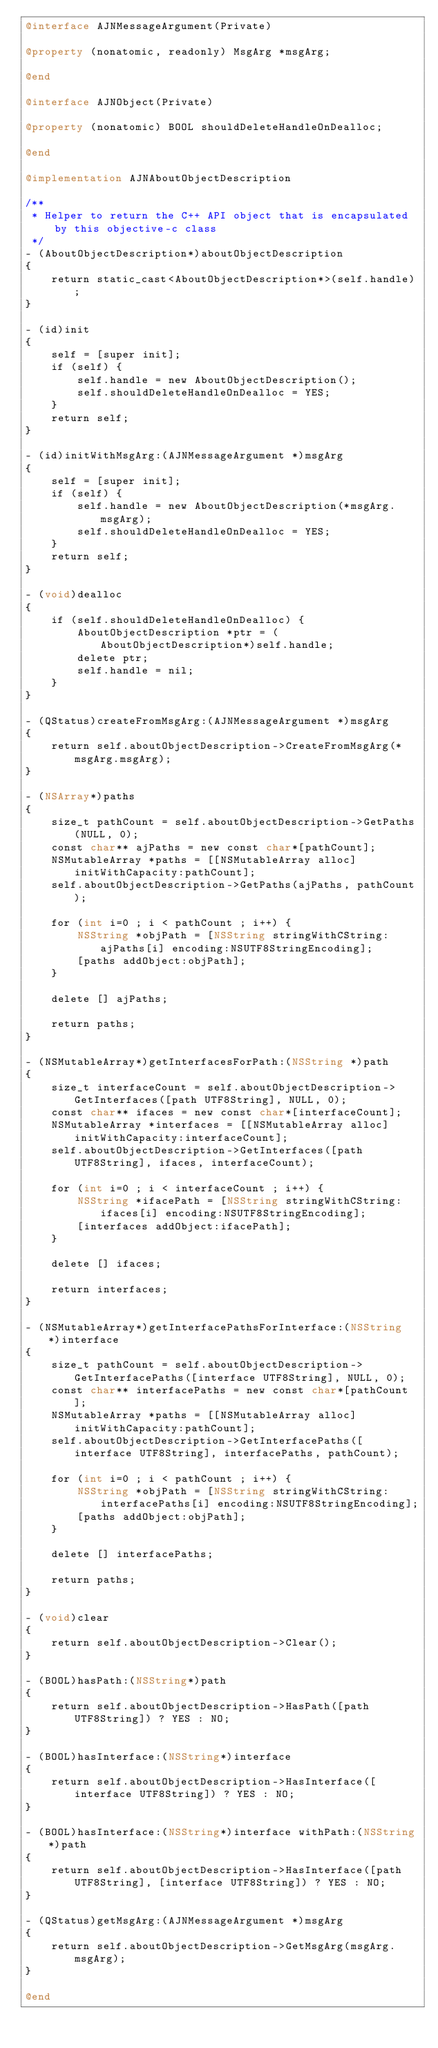<code> <loc_0><loc_0><loc_500><loc_500><_ObjectiveC_>@interface AJNMessageArgument(Private)

@property (nonatomic, readonly) MsgArg *msgArg;

@end

@interface AJNObject(Private)

@property (nonatomic) BOOL shouldDeleteHandleOnDealloc;

@end

@implementation AJNAboutObjectDescription

/**
 * Helper to return the C++ API object that is encapsulated by this objective-c class
 */
- (AboutObjectDescription*)aboutObjectDescription
{
    return static_cast<AboutObjectDescription*>(self.handle);
}

- (id)init
{
    self = [super init];
    if (self) {
        self.handle = new AboutObjectDescription();
        self.shouldDeleteHandleOnDealloc = YES;
    }
    return self;
}

- (id)initWithMsgArg:(AJNMessageArgument *)msgArg
{
    self = [super init];
    if (self) {
        self.handle = new AboutObjectDescription(*msgArg.msgArg);
        self.shouldDeleteHandleOnDealloc = YES;
    }
    return self;
}

- (void)dealloc
{
    if (self.shouldDeleteHandleOnDealloc) {
        AboutObjectDescription *ptr = (AboutObjectDescription*)self.handle;
        delete ptr;
        self.handle = nil;
    }
}

- (QStatus)createFromMsgArg:(AJNMessageArgument *)msgArg
{
    return self.aboutObjectDescription->CreateFromMsgArg(*msgArg.msgArg);
}

- (NSArray*)paths
{
    size_t pathCount = self.aboutObjectDescription->GetPaths(NULL, 0);
    const char** ajPaths = new const char*[pathCount];
    NSMutableArray *paths = [[NSMutableArray alloc] initWithCapacity:pathCount];
    self.aboutObjectDescription->GetPaths(ajPaths, pathCount);

    for (int i=0 ; i < pathCount ; i++) {
        NSString *objPath = [NSString stringWithCString:ajPaths[i] encoding:NSUTF8StringEncoding];
        [paths addObject:objPath];
    }

    delete [] ajPaths;

    return paths;
}

- (NSMutableArray*)getInterfacesForPath:(NSString *)path
{
    size_t interfaceCount = self.aboutObjectDescription->GetInterfaces([path UTF8String], NULL, 0);
    const char** ifaces = new const char*[interfaceCount];
    NSMutableArray *interfaces = [[NSMutableArray alloc] initWithCapacity:interfaceCount];
    self.aboutObjectDescription->GetInterfaces([path UTF8String], ifaces, interfaceCount);

    for (int i=0 ; i < interfaceCount ; i++) {
        NSString *ifacePath = [NSString stringWithCString:ifaces[i] encoding:NSUTF8StringEncoding];
        [interfaces addObject:ifacePath];
    }

    delete [] ifaces;

    return interfaces;
}

- (NSMutableArray*)getInterfacePathsForInterface:(NSString *)interface
{
    size_t pathCount = self.aboutObjectDescription->GetInterfacePaths([interface UTF8String], NULL, 0);
    const char** interfacePaths = new const char*[pathCount];
    NSMutableArray *paths = [[NSMutableArray alloc] initWithCapacity:pathCount];
    self.aboutObjectDescription->GetInterfacePaths([interface UTF8String], interfacePaths, pathCount);

    for (int i=0 ; i < pathCount ; i++) {
        NSString *objPath = [NSString stringWithCString:interfacePaths[i] encoding:NSUTF8StringEncoding];
        [paths addObject:objPath];
    }

    delete [] interfacePaths;

    return paths;
}

- (void)clear
{
    return self.aboutObjectDescription->Clear();
}

- (BOOL)hasPath:(NSString*)path
{
    return self.aboutObjectDescription->HasPath([path UTF8String]) ? YES : NO;
}

- (BOOL)hasInterface:(NSString*)interface
{
    return self.aboutObjectDescription->HasInterface([interface UTF8String]) ? YES : NO;
}

- (BOOL)hasInterface:(NSString*)interface withPath:(NSString*)path
{
    return self.aboutObjectDescription->HasInterface([path UTF8String], [interface UTF8String]) ? YES : NO;
}

- (QStatus)getMsgArg:(AJNMessageArgument *)msgArg
{
    return self.aboutObjectDescription->GetMsgArg(msgArg.msgArg);
}

@end
</code> 